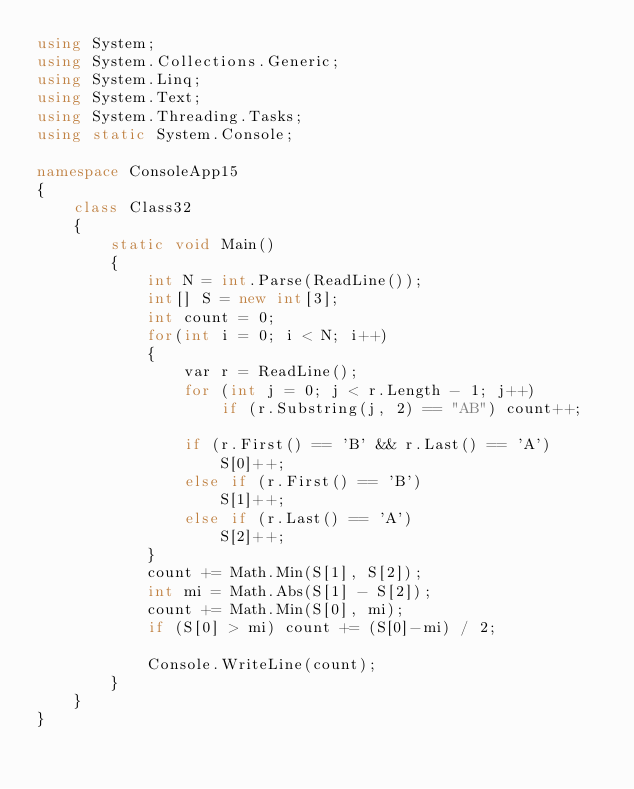<code> <loc_0><loc_0><loc_500><loc_500><_C#_>using System;
using System.Collections.Generic;
using System.Linq;
using System.Text;
using System.Threading.Tasks;
using static System.Console;

namespace ConsoleApp15
{
    class Class32
    {
        static void Main()
        {
            int N = int.Parse(ReadLine());
            int[] S = new int[3];
            int count = 0;
            for(int i = 0; i < N; i++)
            {
                var r = ReadLine();
                for (int j = 0; j < r.Length - 1; j++)
                    if (r.Substring(j, 2) == "AB") count++;

                if (r.First() == 'B' && r.Last() == 'A')
                    S[0]++;
                else if (r.First() == 'B')
                    S[1]++;
                else if (r.Last() == 'A')
                    S[2]++;
            }
            count += Math.Min(S[1], S[2]);
            int mi = Math.Abs(S[1] - S[2]);
            count += Math.Min(S[0], mi);
            if (S[0] > mi) count += (S[0]-mi) / 2;

            Console.WriteLine(count);
        }
    }
}
</code> 